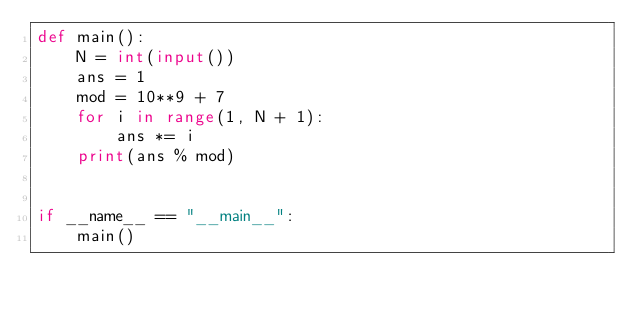<code> <loc_0><loc_0><loc_500><loc_500><_Python_>def main():
    N = int(input())
    ans = 1
    mod = 10**9 + 7
    for i in range(1, N + 1):
        ans *= i
    print(ans % mod)


if __name__ == "__main__":
    main()
</code> 